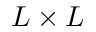Convert formula to latex. <formula><loc_0><loc_0><loc_500><loc_500>L \times L</formula> 